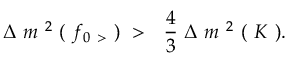<formula> <loc_0><loc_0><loc_500><loc_500>\Delta \ m ^ { \ 2 } \ ( \ f _ { 0 \ > } \ ) \ > \quad f r a c { 4 } { 3 } \ \Delta \ m ^ { \ 2 } \ ( \ K \ ) .</formula> 